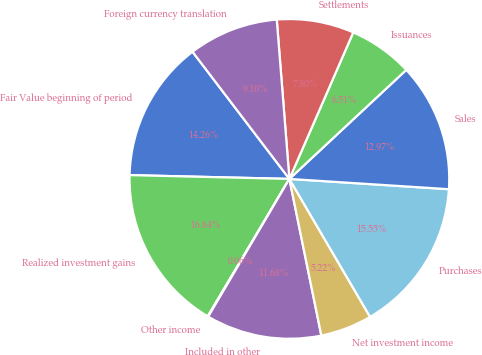<chart> <loc_0><loc_0><loc_500><loc_500><pie_chart><fcel>Fair Value beginning of period<fcel>Realized investment gains<fcel>Other income<fcel>Included in other<fcel>Net investment income<fcel>Purchases<fcel>Sales<fcel>Issuances<fcel>Settlements<fcel>Foreign currency translation<nl><fcel>14.26%<fcel>16.84%<fcel>0.06%<fcel>11.68%<fcel>5.22%<fcel>15.55%<fcel>12.97%<fcel>6.51%<fcel>7.8%<fcel>9.1%<nl></chart> 